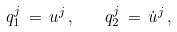Convert formula to latex. <formula><loc_0><loc_0><loc_500><loc_500>q _ { 1 } ^ { j } \, = \, u ^ { j } \, { , } \quad q _ { 2 } ^ { j } \, = \, \dot { u } ^ { j } \, { , }</formula> 